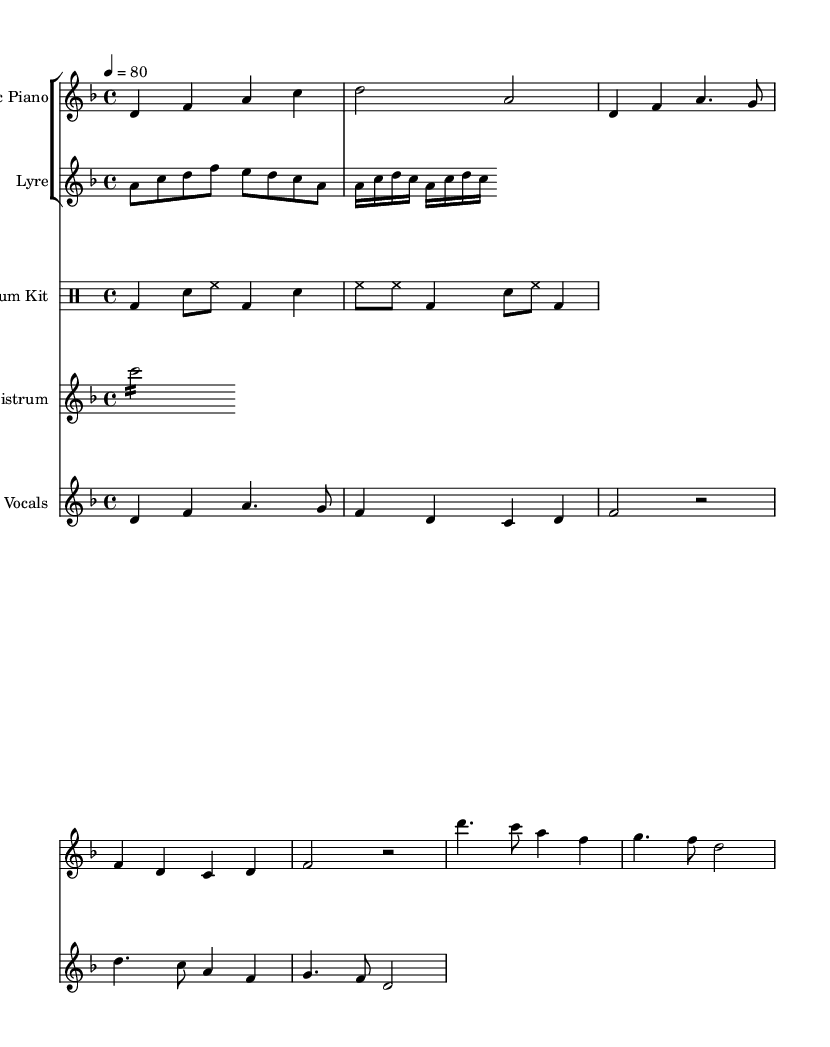What is the key signature of this music? The key signature is determined by looking for sharps or flats at the beginning of the staff. In this case, there are no sharps or flats, indicating it is in a minor key signature. Upon noting the key of D minor, it has one flat, which is B flat.
Answer: D minor, one flat What is the time signature of this music? The time signature is located at the beginning of the staff and is represented by the numbers above the staff lines. Here, it is indicated as 4 over 4, meaning there are four beats in each measure and a quarter note receives one beat.
Answer: 4/4 What is the tempo marking of this music? The tempo marking is indicated at the beginning of the piece. In this case, it states "4 = 80," meaning there should be 80 beats per minute, with each beat corresponding to a quarter note.
Answer: 80 How many beats does a measure contain? The answer to this question can be derived from the time signature, which is indicated as 4/4 in this sheet music. Since the upper number of the time signature shows how many beats are in each measure, it can be clearly seen that there are four beats.
Answer: Four beats What instruments are used in this piece? The instruments are listed in the score, where each staff is labeled with the instrument name. The piece features Electric Piano, Lyre, Drum Kit, Sistrum, and Vocals, all of which are included in the staff groupings.
Answer: Electric Piano, Lyre, Drum Kit, Sistrum, Vocals What historical instrument is prominently featured in this composition? The Lyre is an ancient musical instrument that may be identified in the score as one of the staves. This points to its historical significance, used in various ancient musical traditions.
Answer: Lyre What lyrical theme is expressed in the song? By examining the lyrics under the vocal part, we see that they cover themes related to echoes of antiquity and the passage of time, bridging historical elements with contemporary expression, which indicates the thematic focus of the music.
Answer: Echoes of antiquity 